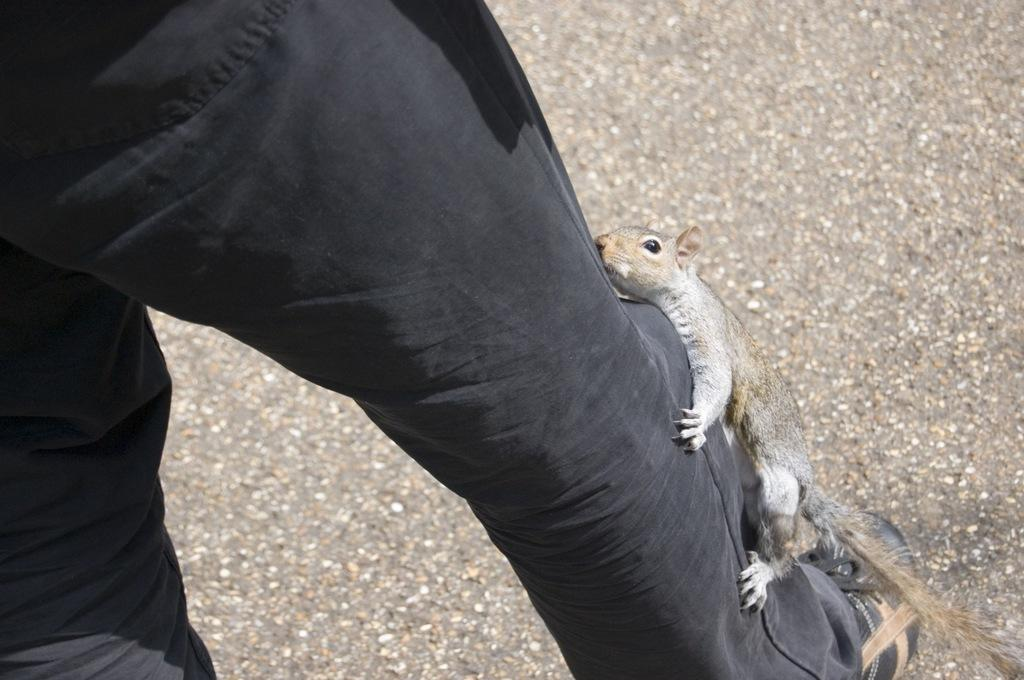What is on the person's leg in the image? There is an animal on the person's leg in the image. What type of footwear is visible in the image? There is a shoe visible in the image. What can be seen beneath the person and the animal? The ground is visible in the image. What letter is being written by the animal on the person's leg in the image? There is no letter being written in the image; it features an animal on a person's leg and a shoe on the ground. Can you see a horn on the animal in the image? There is no horn visible on the animal in the image. 